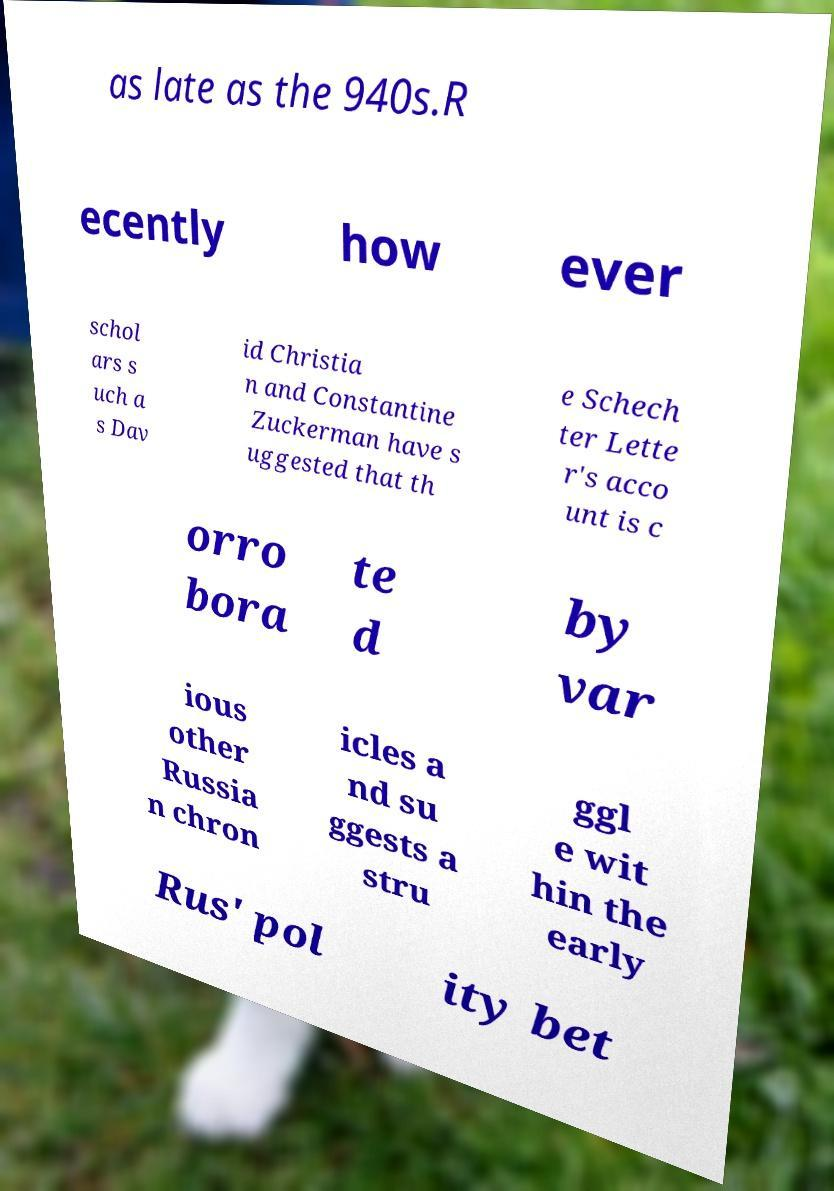I need the written content from this picture converted into text. Can you do that? as late as the 940s.R ecently how ever schol ars s uch a s Dav id Christia n and Constantine Zuckerman have s uggested that th e Schech ter Lette r's acco unt is c orro bora te d by var ious other Russia n chron icles a nd su ggests a stru ggl e wit hin the early Rus' pol ity bet 